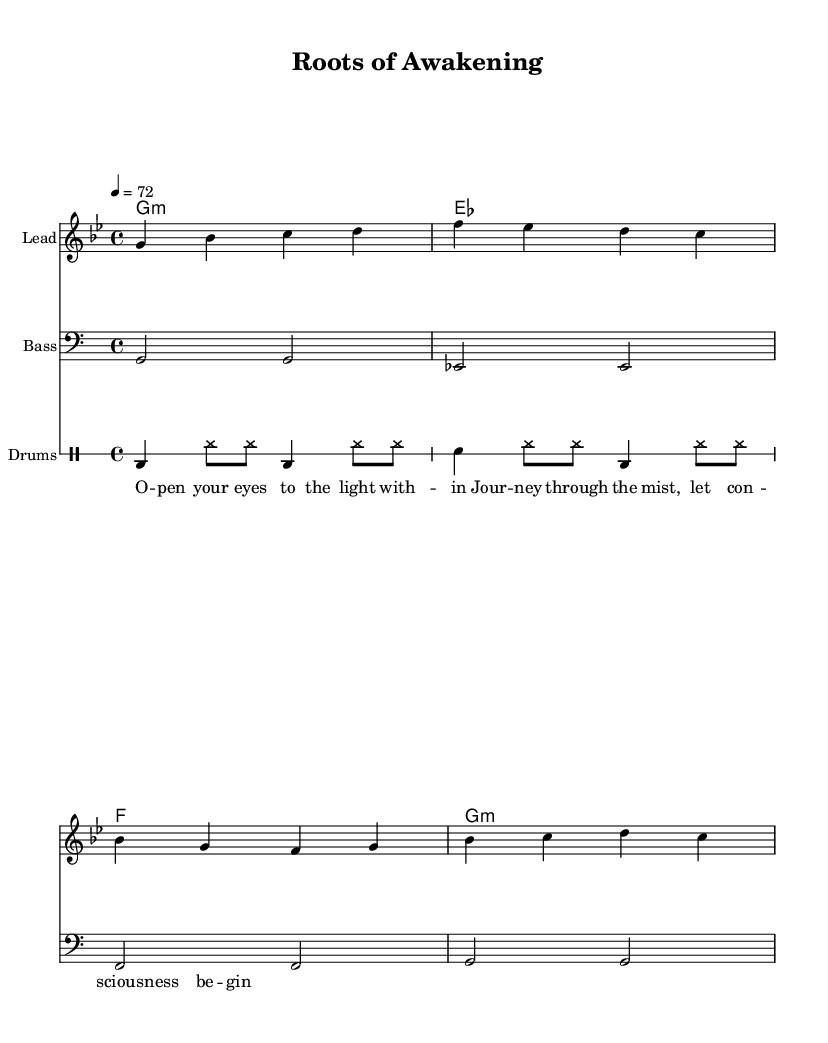What is the key signature of this music? The key signature is G minor, which has two flats: B flat and E flat.
Answer: G minor What is the time signature of this music? The time signature is found at the beginning of the score, and it shows 4 beats per measure.
Answer: 4/4 What is the tempo marking for this piece? The tempo marking is indicated by the number, which specifies beats per minute; here it states "4 = 72."
Answer: 72 How many measures are in the melody? By counting the groups of notes separated by bar lines in the melody, we see there are 4 measures.
Answer: 4 measures What rhythmic pattern is used in the drums? The drum pattern comprises a series of bass and snare hits along with hi-hat accents, typical in reggae styling.
Answer: Bass and snare pattern What phrase appears in the lyrics that suggests spiritual awakening? The phrase "open your eyes to the light within" explicitly references gaining awareness and enlightenment.
Answer: "Open your eyes to the light within." What chord progression is used in the harmonies? The chord progression uses the G minor chord followed by E flat major and F major, which is characteristic of reggae music.
Answer: G minor, E flat, F major 